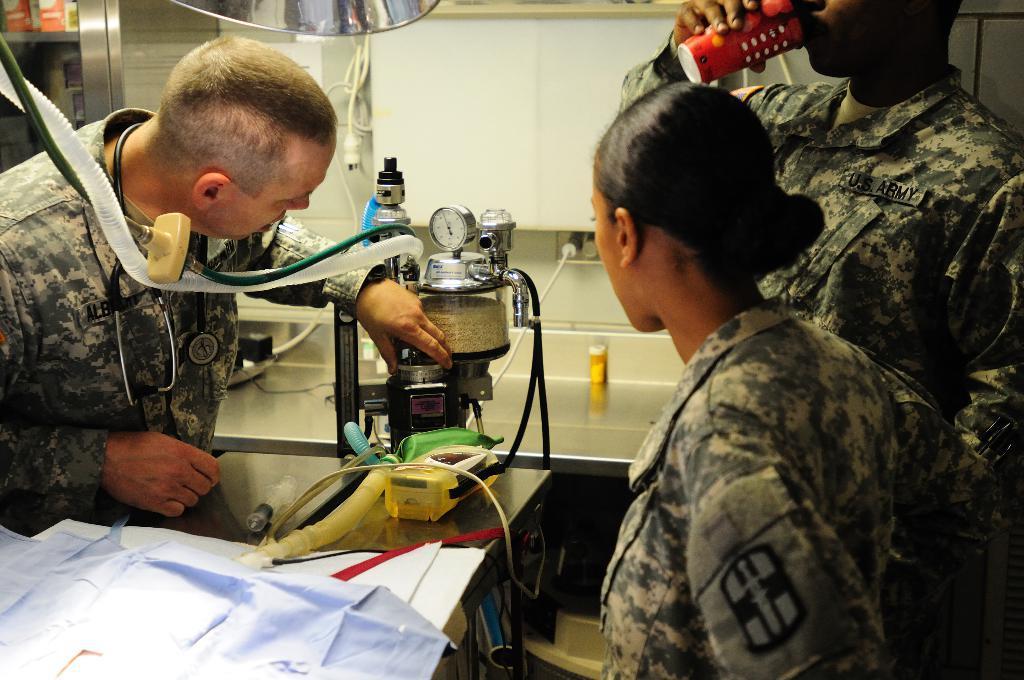Can you describe this image briefly? In this picture I can see three persons, there is a person holding a cup, there is a stethoscope, there is a kind of machine and there are some other items on the table, and in the background there are some objects. 